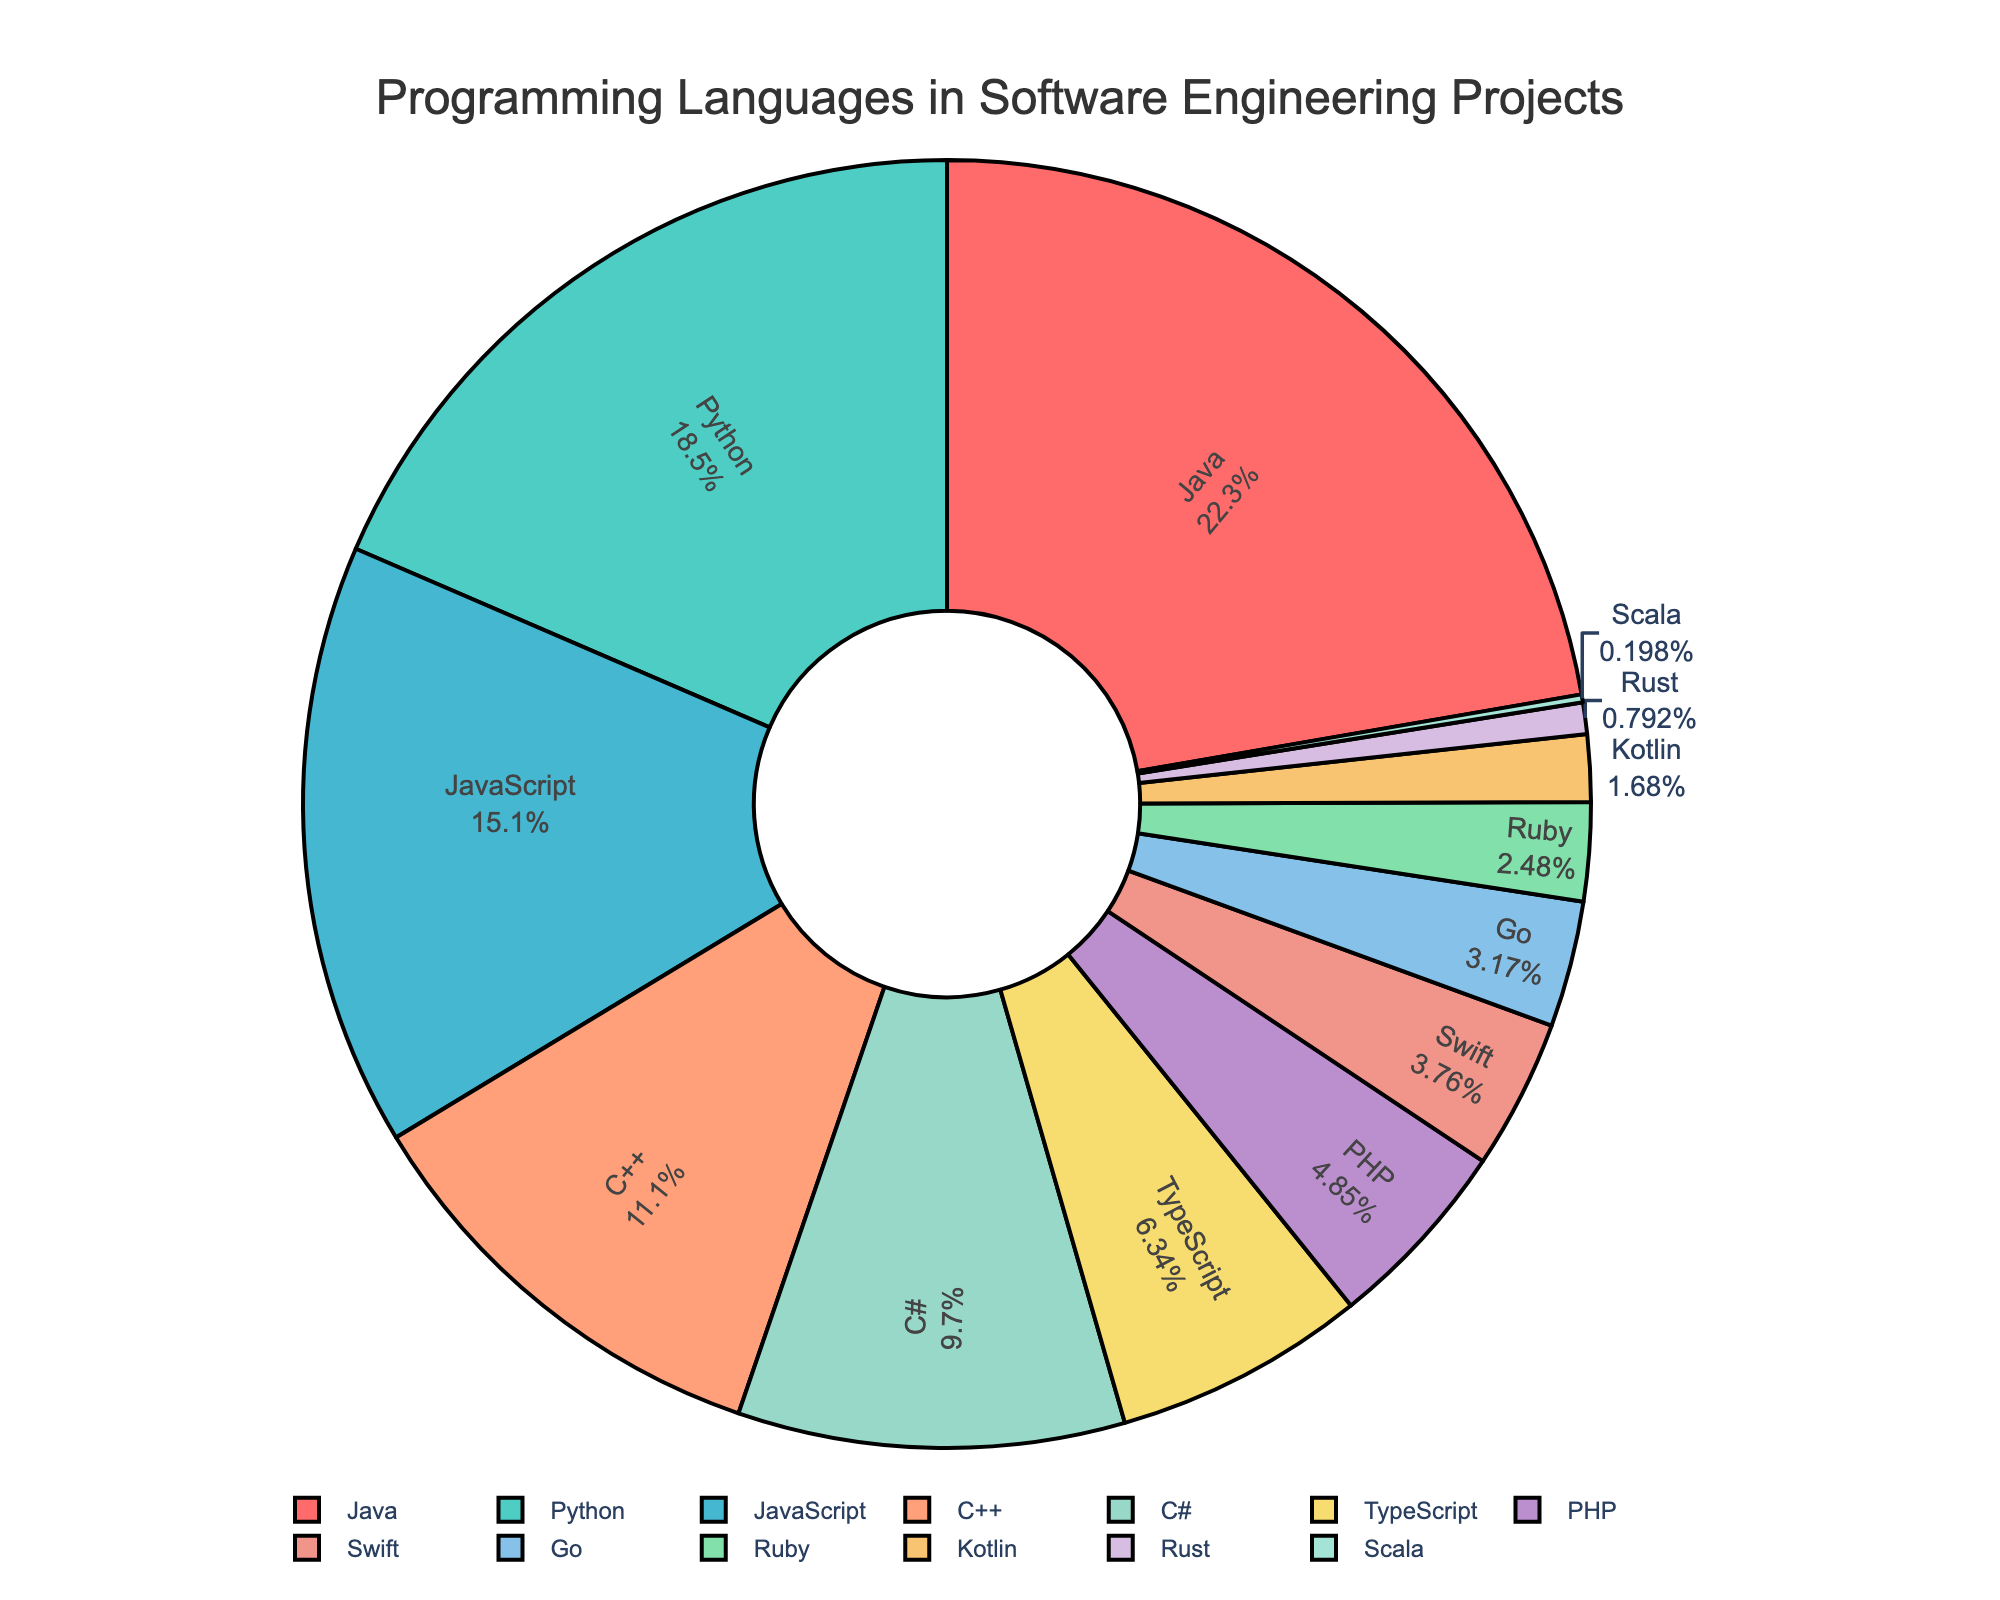Which programming language has the largest slice in the pie chart and what percentage does it represent? The largest slice in the pie chart is represented by Java, which is indicated by having the highest percentage. Upon examining the chart, it is seen that Java occupies a 22.5% share.
Answer: Java, 22.5% How much larger is the percentage of Python compared to Go? To find how much larger Python's percentage is compared to Go's, subtract the percentage of Go from that of Python. Python is 18.7% and Go is 3.2%, so 18.7% - 3.2% = 15.5%.
Answer: 15.5% If you combine the percentages of JavaScript, C++, and C#, what is their total percentage? To find the combined percentage, add the percentages for JavaScript (15.3%), C++ (11.2%), and C# (9.8%). The total is 15.3% + 11.2% + 9.8% = 36.3%.
Answer: 36.3% Which languages have a percentage less than but closest to TypeScript? TypeScript is at 6.4%. The next closest percentages below are PHP with 4.9% and Swift with 3.8%. Upon comparing, PHP is the closest to 6.4% without exceeding it.
Answer: PHP, Swift What is the color of the slice representing C++? The pie chart shows C++ represented by a specific color. Under visual inspection, C++ is depicted in light blue.
Answer: light blue What is the percentage difference between the language with the smallest percentage and the language with the largest percentage? To find the difference between the smallest and largest percentages, subtract the smallest percentage (Scala at 0.2%) from the largest percentage (Java at 22.5%). The difference is 22.5% - 0.2% = 22.3%.
Answer: 22.3% If you were to group all programming languages into those that individually have more than 10% share and those with 10% or less, how many languages fall into each category? First, identify languages with more than 10%: Java (22.5%), Python (18.7%), and JavaScript (15.3%). Those with 10% or less are C++ (11.2%), C# (9.8%), TypeScript (6.4%), PHP (4.9%), Swift (3.8%), Go (3.2%), Ruby (2.5%), Kotlin (1.7%), Rust (0.8%), and Scala (0.2%). Count the numbers for each group: 3 languages above 10% and 10 languages at or below 10%.
Answer: More than 10%: 3, 10% or less: 10 